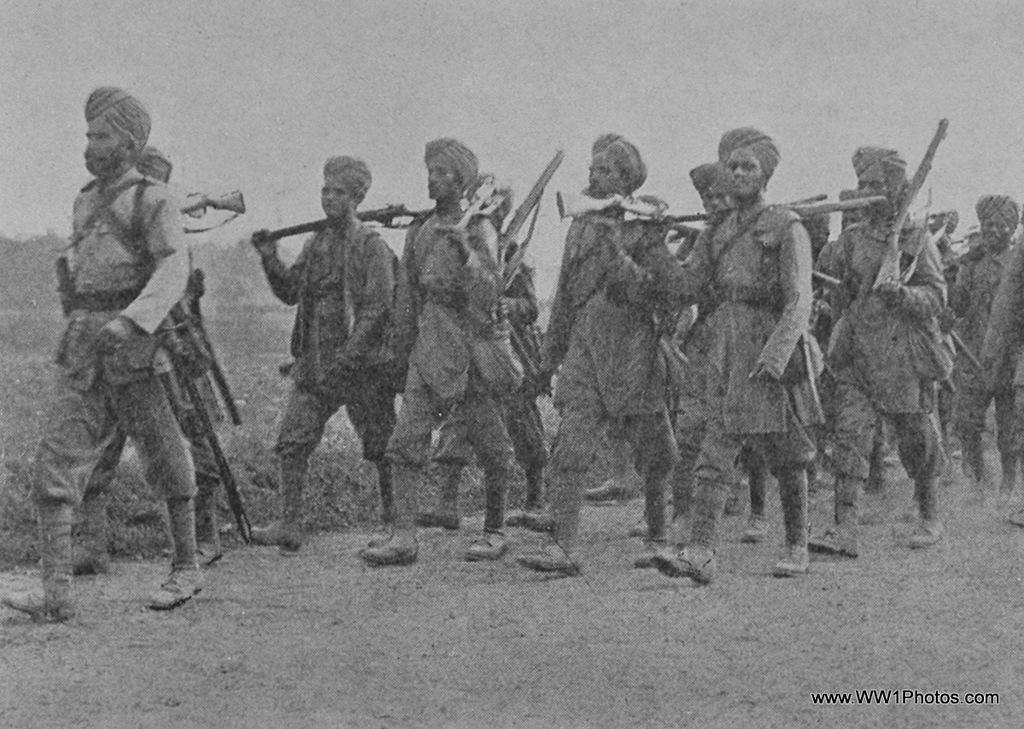Could you give a brief overview of what you see in this image? In this picture there are men in the center of the image, by holding guns in their hands. 